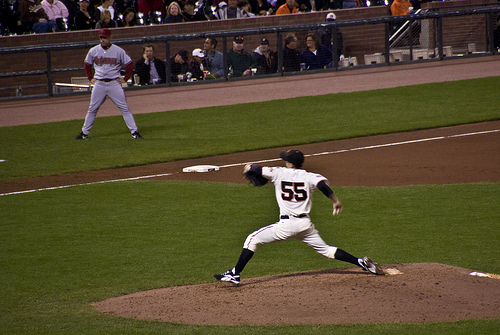Is there either a hat or a scarf that is black? Yes, there is a black hat visible on the pitcher. 